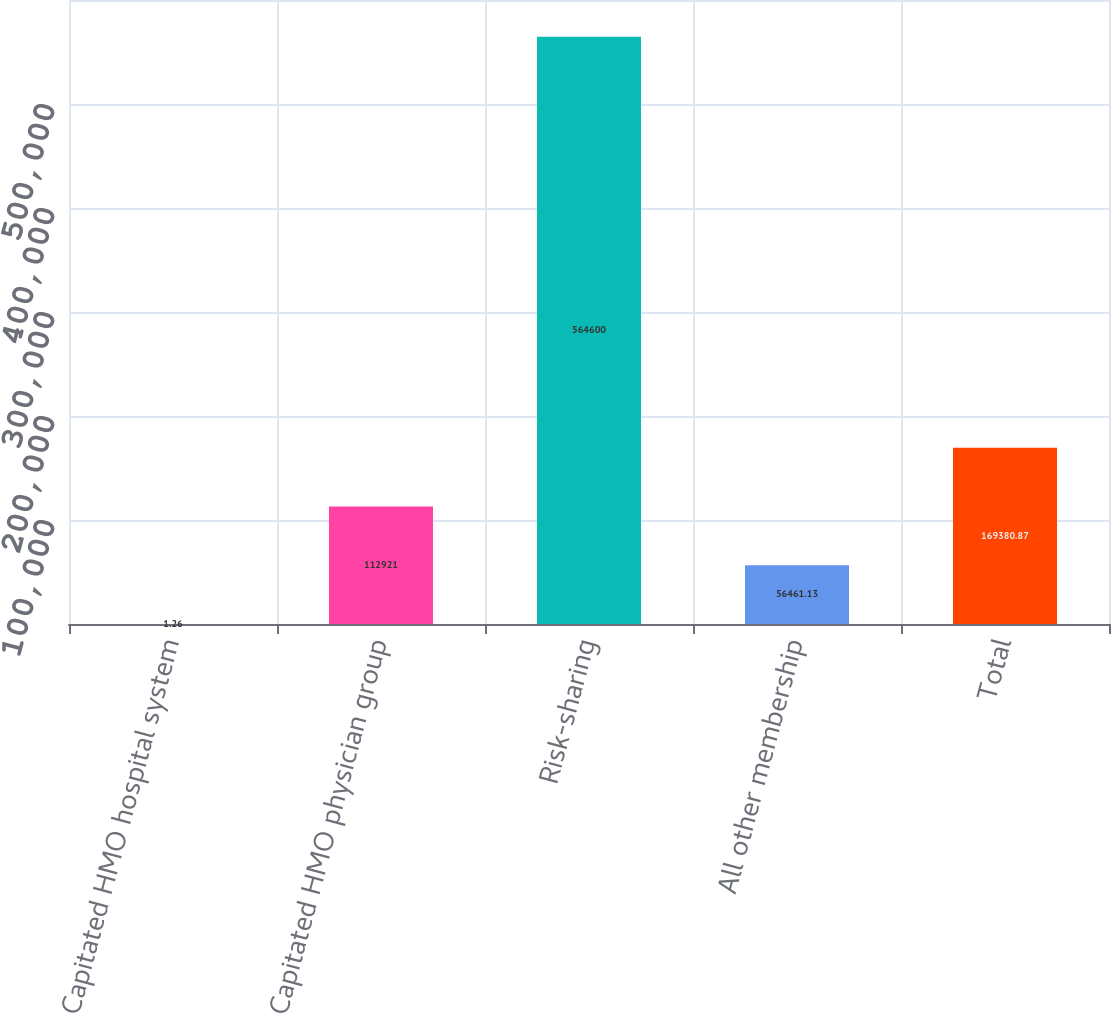<chart> <loc_0><loc_0><loc_500><loc_500><bar_chart><fcel>Capitated HMO hospital system<fcel>Capitated HMO physician group<fcel>Risk-sharing<fcel>All other membership<fcel>Total<nl><fcel>1.26<fcel>112921<fcel>564600<fcel>56461.1<fcel>169381<nl></chart> 